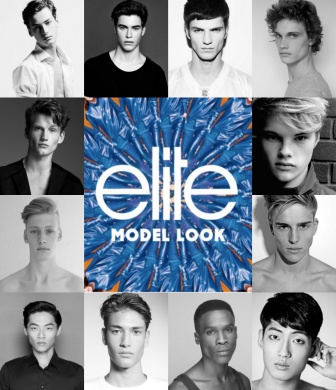Create an advertisement script for the Elite Model Look competition. In a world where style meets ambition, where individuality shines, comes an event that redefines modeling: The Elite Model Look Competition. Witness the epitome of talent, diversity, and beauty as aspiring models from every corner of the globe converge. Captured in timeless black and white, they exude confidence, determination, and the raw essence of modeling.

At the heart of this journey lies the vibrant Elite Model Look logo, a beacon of opportunity and transformation. It’s more than a competition; it’s a gateway to dreams. Join us as we celebrate uniqueness, showcasing the next generation of models ready to take the world by storm. Elite Model Look – Where Legends Begin. 